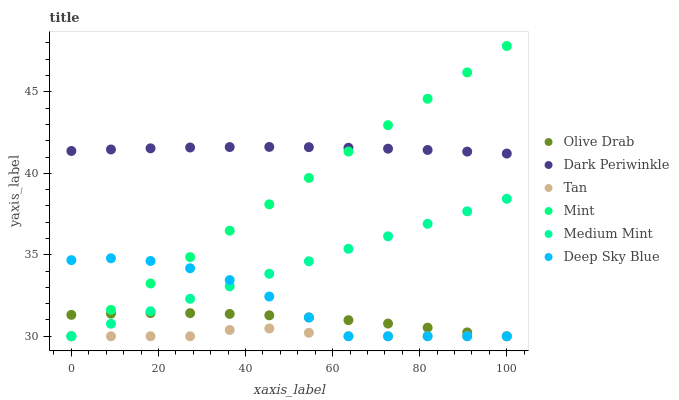Does Tan have the minimum area under the curve?
Answer yes or no. Yes. Does Dark Periwinkle have the maximum area under the curve?
Answer yes or no. Yes. Does Deep Sky Blue have the minimum area under the curve?
Answer yes or no. No. Does Deep Sky Blue have the maximum area under the curve?
Answer yes or no. No. Is Mint the smoothest?
Answer yes or no. Yes. Is Deep Sky Blue the roughest?
Answer yes or no. Yes. Is Tan the smoothest?
Answer yes or no. No. Is Tan the roughest?
Answer yes or no. No. Does Medium Mint have the lowest value?
Answer yes or no. Yes. Does Dark Periwinkle have the lowest value?
Answer yes or no. No. Does Mint have the highest value?
Answer yes or no. Yes. Does Deep Sky Blue have the highest value?
Answer yes or no. No. Is Tan less than Dark Periwinkle?
Answer yes or no. Yes. Is Dark Periwinkle greater than Deep Sky Blue?
Answer yes or no. Yes. Does Mint intersect Olive Drab?
Answer yes or no. Yes. Is Mint less than Olive Drab?
Answer yes or no. No. Is Mint greater than Olive Drab?
Answer yes or no. No. Does Tan intersect Dark Periwinkle?
Answer yes or no. No. 